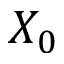Convert formula to latex. <formula><loc_0><loc_0><loc_500><loc_500>X _ { 0 }</formula> 